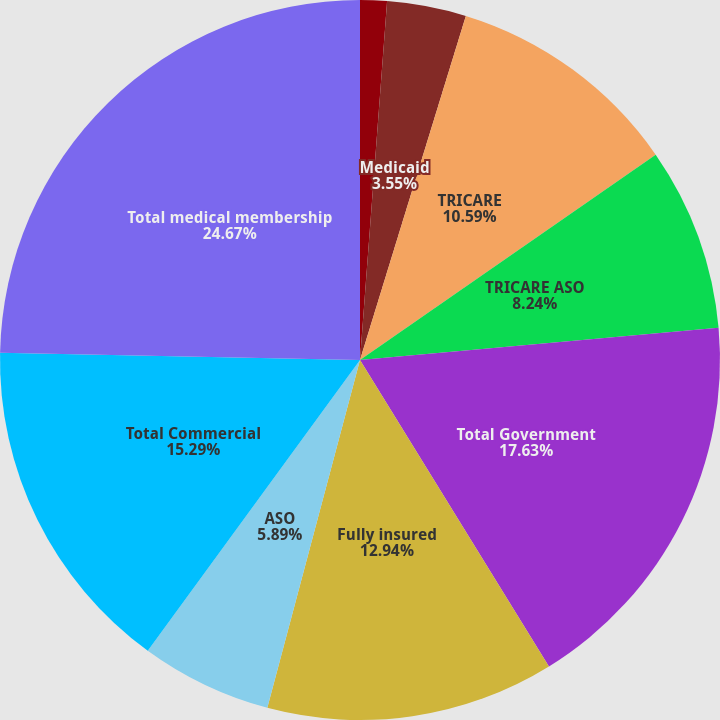Convert chart. <chart><loc_0><loc_0><loc_500><loc_500><pie_chart><fcel>Medicare Advantage<fcel>Medicaid<fcel>TRICARE<fcel>TRICARE ASO<fcel>Total Government<fcel>Fully insured<fcel>ASO<fcel>Total Commercial<fcel>Total medical membership<nl><fcel>1.2%<fcel>3.55%<fcel>10.59%<fcel>8.24%<fcel>17.63%<fcel>12.94%<fcel>5.89%<fcel>15.29%<fcel>24.68%<nl></chart> 